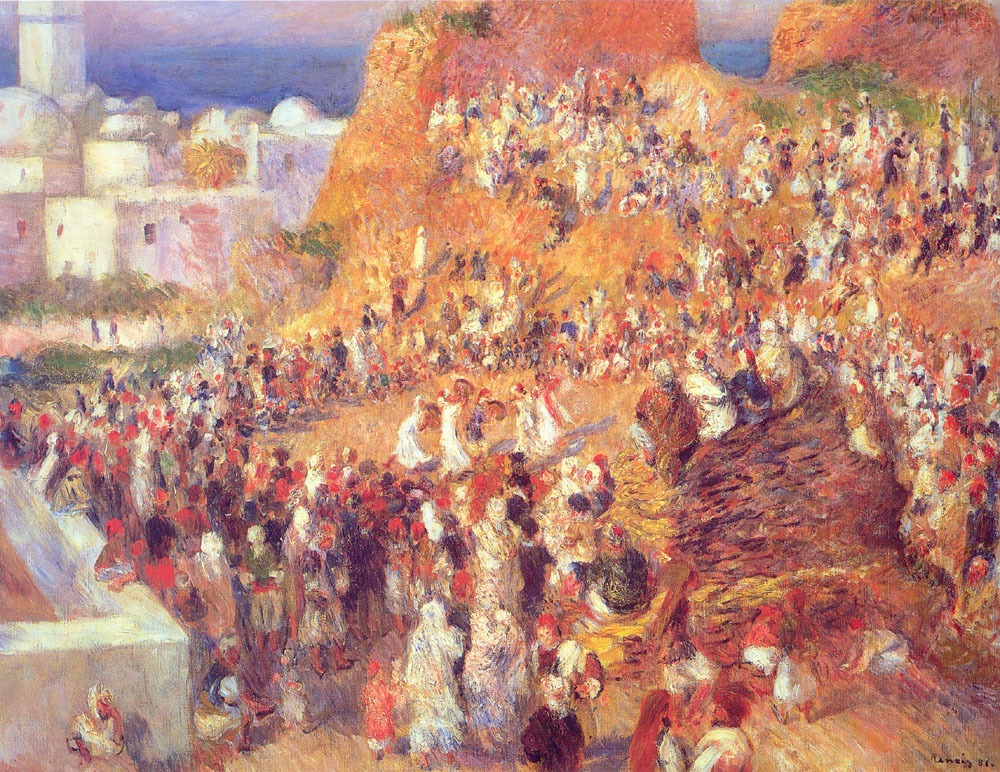Explain the visual content of the image in great detail. The image showcases an impressionist painting of a lively Mediterranean market scene. The painting is filled with an abundance of people, buildings, and various objects, all brought to life through a vibrant and dynamic color palette. Dominated by warm hues such as reds, oranges, and yellows, it conveys a bright and sunny day. The artist employed loose and fluid brushstrokes, characteristic of the impressionist style, creating a sense of motion and life. Individual figures and objects lack fine detail, focusing instead on the overall atmosphere and energy of the scene. The painting beautifully captures the hustle and bustle of a Mediterranean market, highlighting the community's vibrancy and richness through the layers of color and light. 